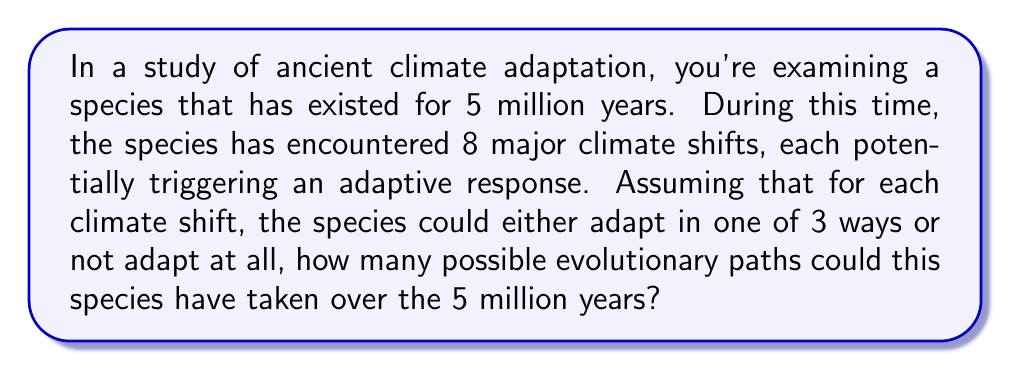Can you answer this question? To solve this problem, we need to consider the following:

1. The species encounters 8 major climate shifts.
2. For each shift, there are 4 possible outcomes: 3 ways to adapt or no adaptation.
3. We need to determine the total number of possible combinations of these outcomes over the 8 shifts.

This scenario can be modeled as a combination with repetition problem, specifically a case of making selections with replacement.

For each climate shift, we have 4 choices, and we make this choice 8 times (once for each shift). The order of these choices matters, as they represent a sequence of events over time.

The formula for this type of problem is:

$$ n^r $$

Where:
$n$ = number of choices for each event
$r$ = number of events

In this case:
$n = 4$ (3 adaptation options + 1 no adaptation option)
$r = 8$ (number of climate shifts)

Therefore, the number of possible evolutionary paths is:

$$ 4^8 = 65,536 $$

This means there are 65,536 possible unique sequences of adaptations (or lack thereof) that the species could have undergone over the 5 million years in response to the 8 major climate shifts.
Answer: $$ 4^8 = 65,536 $$ 